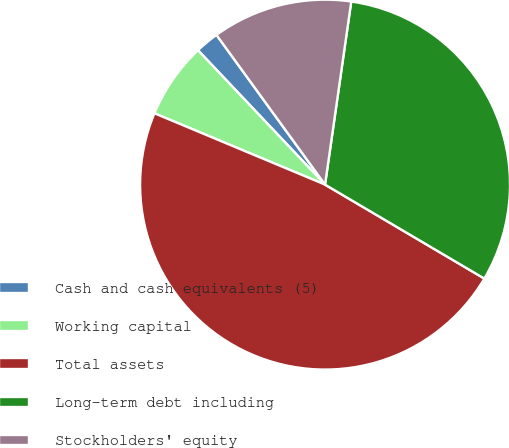<chart> <loc_0><loc_0><loc_500><loc_500><pie_chart><fcel>Cash and cash equivalents (5)<fcel>Working capital<fcel>Total assets<fcel>Long-term debt including<fcel>Stockholders' equity<nl><fcel>2.07%<fcel>6.64%<fcel>47.82%<fcel>31.22%<fcel>12.25%<nl></chart> 